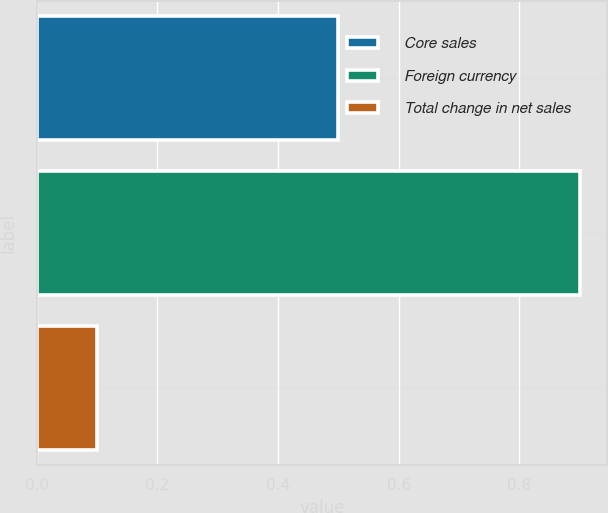<chart> <loc_0><loc_0><loc_500><loc_500><bar_chart><fcel>Core sales<fcel>Foreign currency<fcel>Total change in net sales<nl><fcel>0.5<fcel>0.9<fcel>0.1<nl></chart> 